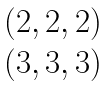Convert formula to latex. <formula><loc_0><loc_0><loc_500><loc_500>\begin{matrix} ( 2 , 2 , 2 ) \\ ( 3 , 3 , 3 ) \end{matrix}</formula> 